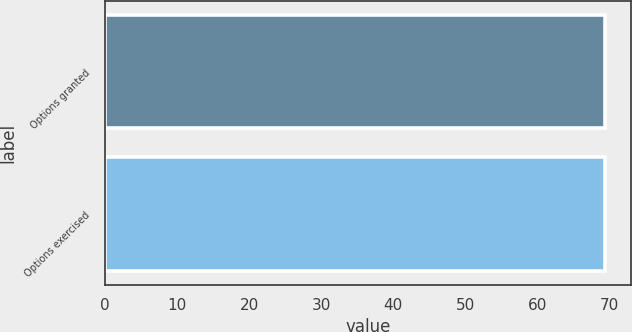Convert chart to OTSL. <chart><loc_0><loc_0><loc_500><loc_500><bar_chart><fcel>Options granted<fcel>Options exercised<nl><fcel>69.34<fcel>69.44<nl></chart> 